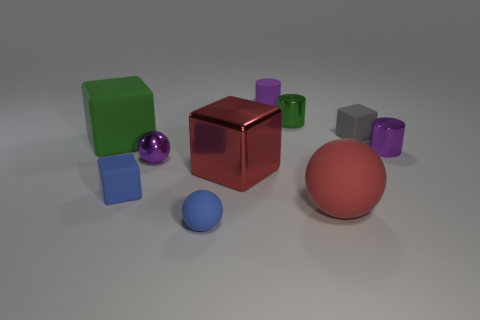How big is the purple cylinder that is behind the gray thing?
Keep it short and to the point. Small. The large object that is the same material as the tiny green thing is what shape?
Provide a short and direct response. Cube. Is there any other thing that is the same color as the matte cylinder?
Provide a succinct answer. Yes. There is a shiny thing that is behind the small matte object to the right of the green cylinder; what color is it?
Ensure brevity in your answer.  Green. How many big things are either green matte things or brown things?
Ensure brevity in your answer.  1. What is the material of the green thing that is the same shape as the gray rubber object?
Your response must be concise. Rubber. What color is the large metal thing?
Make the answer very short. Red. Do the shiny cube and the big rubber ball have the same color?
Give a very brief answer. Yes. How many matte cubes are left of the small purple thing that is behind the purple metal cylinder?
Ensure brevity in your answer.  2. There is a block that is both in front of the green matte cube and left of the large red shiny thing; what is its size?
Provide a succinct answer. Small. 